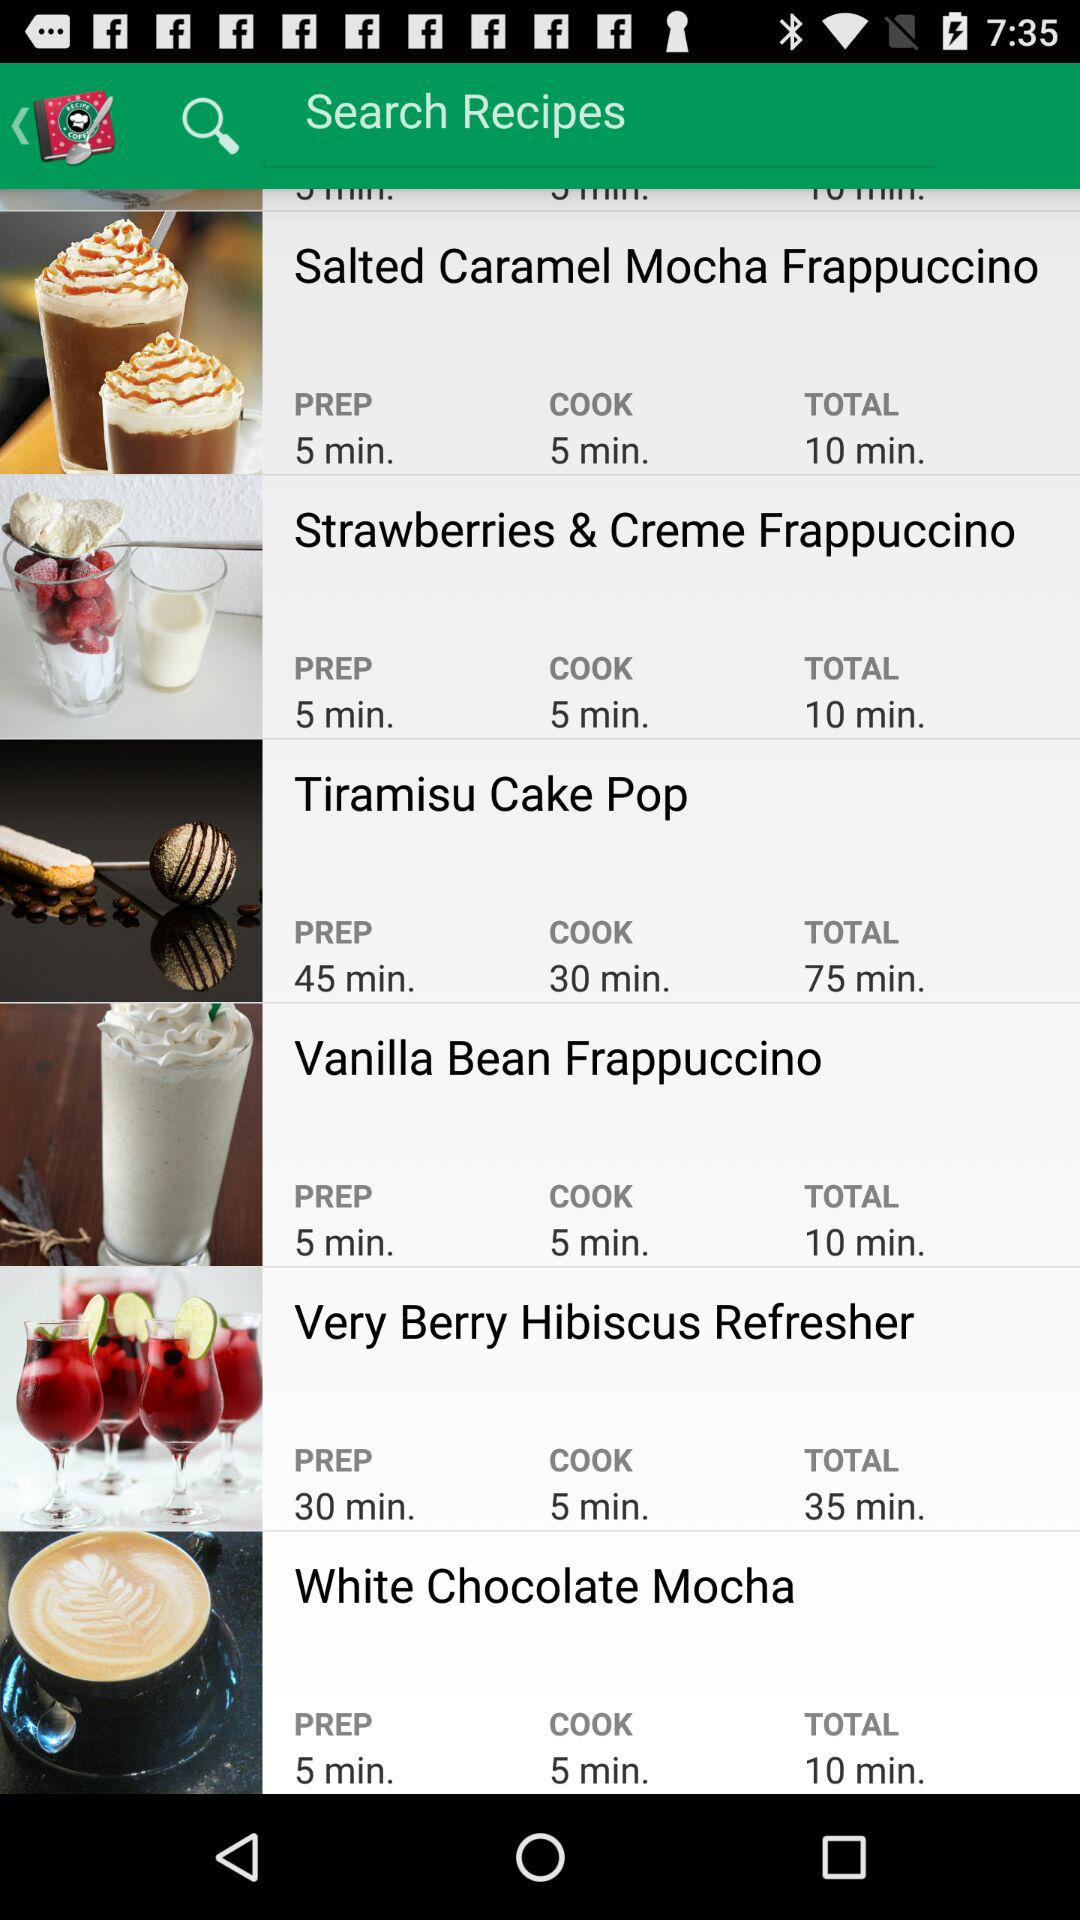How long does it take to make "Salted Caramel Mocha"? It takes 10 minutes to make "Salted Caramel Mocha". 